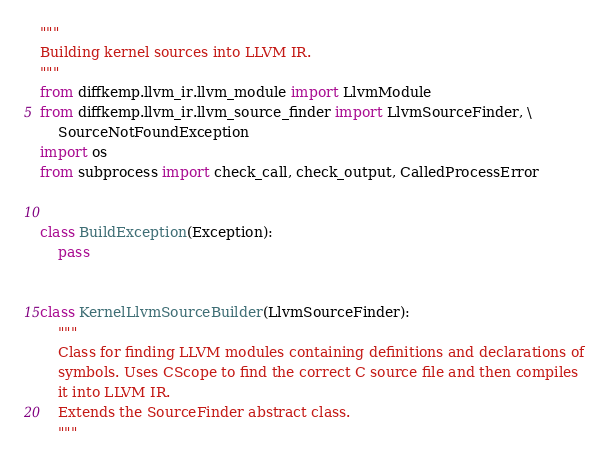Convert code to text. <code><loc_0><loc_0><loc_500><loc_500><_Python_>"""
Building kernel sources into LLVM IR.
"""
from diffkemp.llvm_ir.llvm_module import LlvmModule
from diffkemp.llvm_ir.llvm_source_finder import LlvmSourceFinder, \
    SourceNotFoundException
import os
from subprocess import check_call, check_output, CalledProcessError


class BuildException(Exception):
    pass


class KernelLlvmSourceBuilder(LlvmSourceFinder):
    """
    Class for finding LLVM modules containing definitions and declarations of
    symbols. Uses CScope to find the correct C source file and then compiles
    it into LLVM IR.
    Extends the SourceFinder abstract class.
    """</code> 